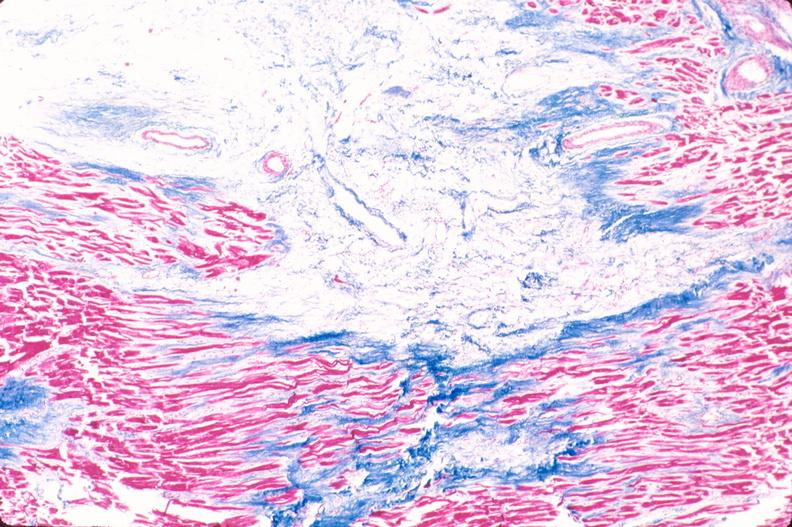where is this in?
Answer the question using a single word or phrase. In heart 